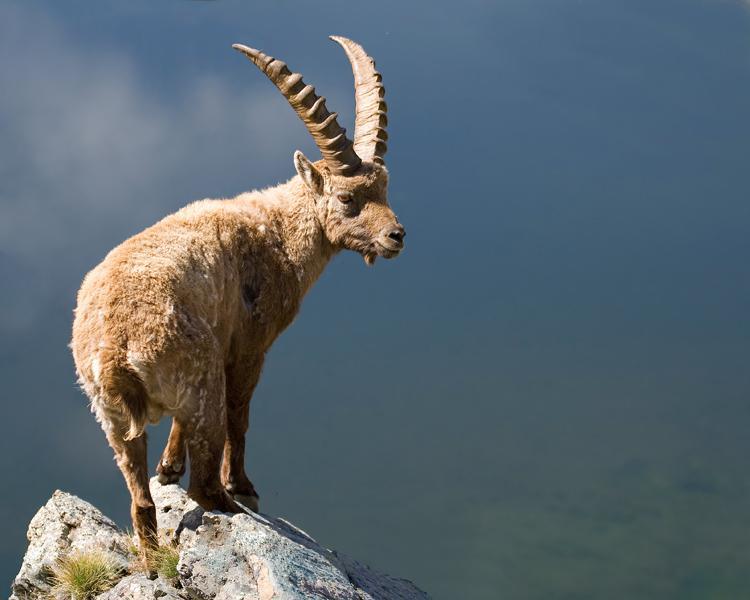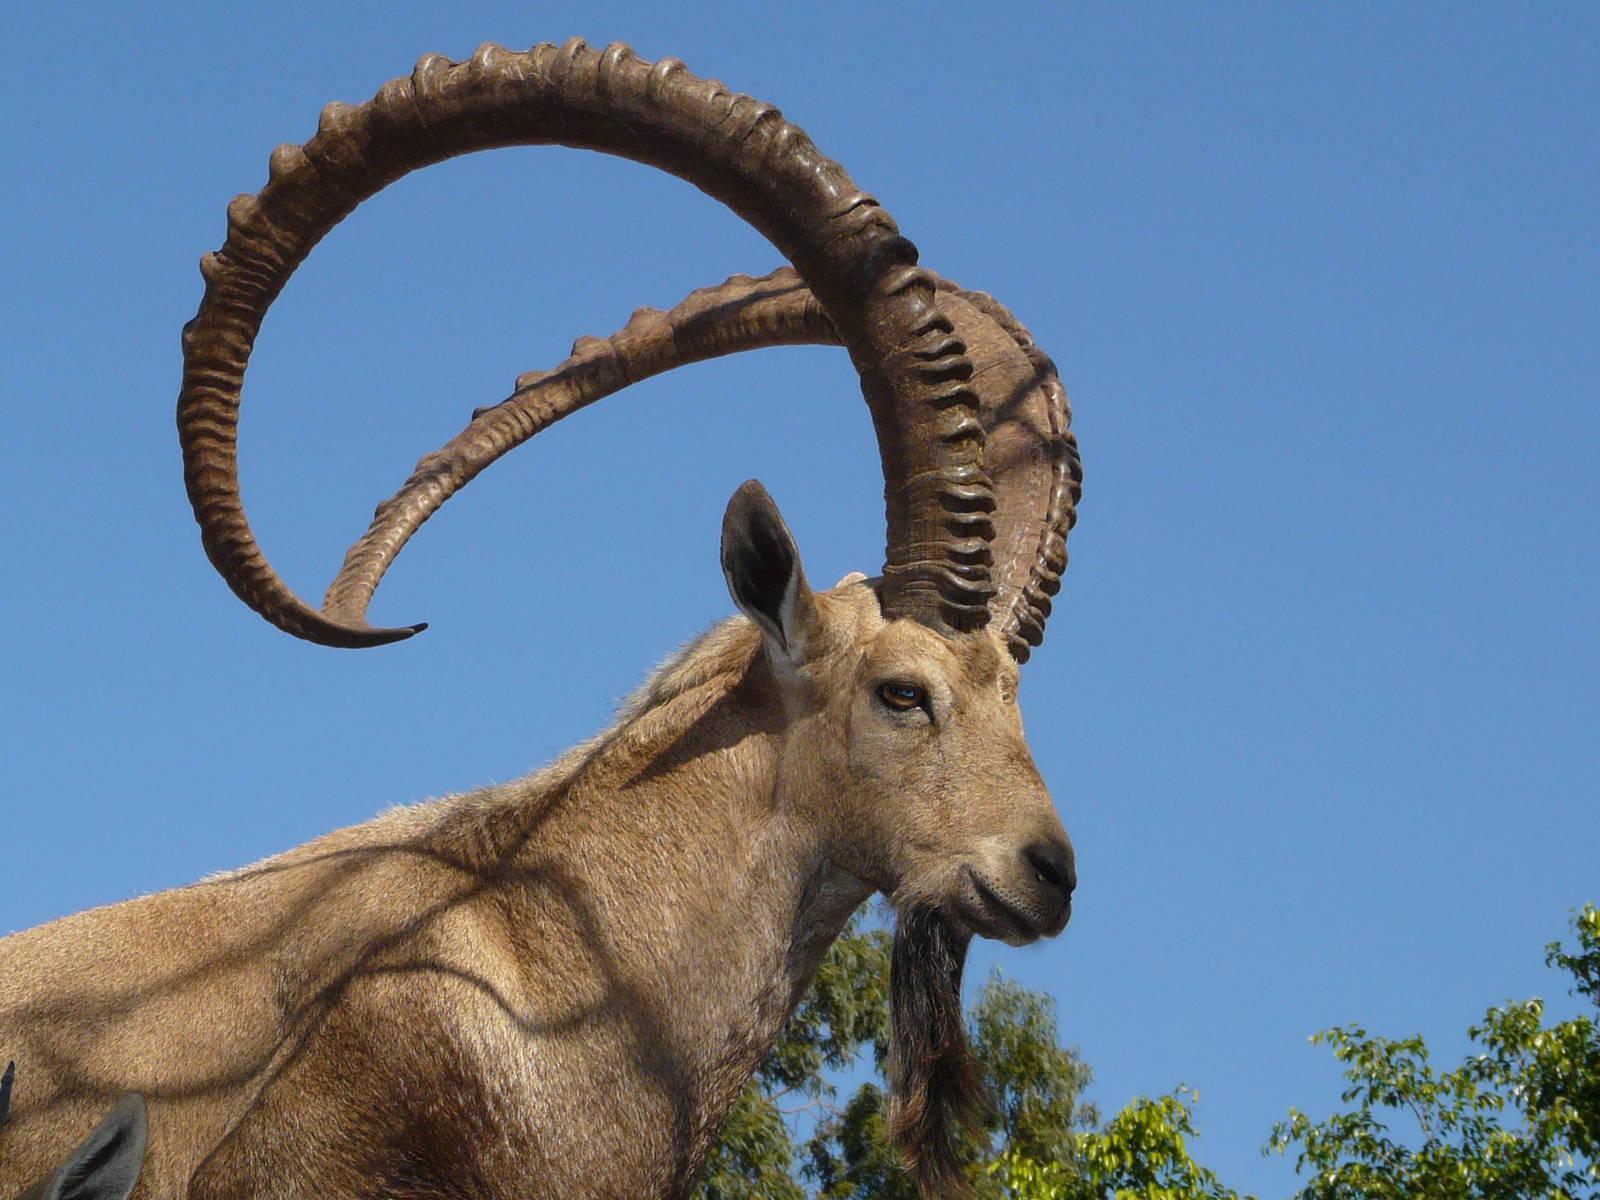The first image is the image on the left, the second image is the image on the right. Given the left and right images, does the statement "Both rams are standing on rocky ground." hold true? Answer yes or no. No. The first image is the image on the left, the second image is the image on the right. Evaluate the accuracy of this statement regarding the images: "Each image shows a long-horned animal standing on a rocky peak, and each animal is looking in the same general direction.". Is it true? Answer yes or no. No. 